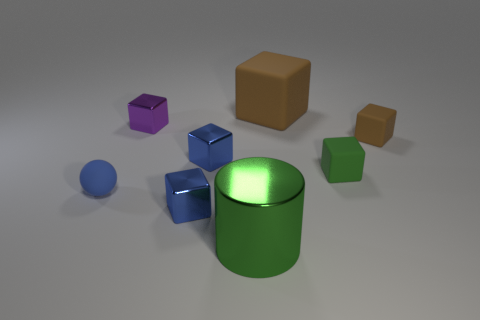What number of purple blocks have the same size as the blue ball?
Give a very brief answer. 1. There is a cube that is the same color as the large metal object; what size is it?
Ensure brevity in your answer.  Small. What number of large objects are green objects or cylinders?
Keep it short and to the point. 1. How many tiny brown cylinders are there?
Ensure brevity in your answer.  0. Is the number of metal cylinders behind the large brown object the same as the number of brown rubber things that are in front of the large shiny cylinder?
Provide a succinct answer. Yes. Are there any objects in front of the tiny brown thing?
Provide a short and direct response. Yes. What color is the cube that is in front of the small matte ball?
Provide a succinct answer. Blue. What material is the brown block that is in front of the brown block that is behind the small brown matte object?
Provide a succinct answer. Rubber. Is the number of big green cylinders on the right side of the big brown rubber block less than the number of tiny purple metallic objects right of the purple shiny cube?
Make the answer very short. No. How many brown things are either tiny metal cubes or matte cubes?
Your answer should be very brief. 2. 